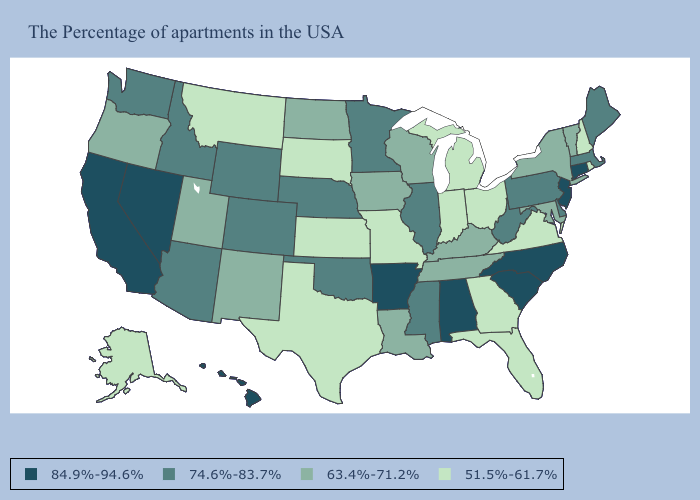Which states have the lowest value in the West?
Short answer required. Montana, Alaska. Among the states that border Missouri , does Tennessee have the highest value?
Be succinct. No. Does the map have missing data?
Write a very short answer. No. What is the value of Texas?
Concise answer only. 51.5%-61.7%. Name the states that have a value in the range 84.9%-94.6%?
Concise answer only. Connecticut, New Jersey, North Carolina, South Carolina, Alabama, Arkansas, Nevada, California, Hawaii. What is the value of New Mexico?
Short answer required. 63.4%-71.2%. Name the states that have a value in the range 84.9%-94.6%?
Short answer required. Connecticut, New Jersey, North Carolina, South Carolina, Alabama, Arkansas, Nevada, California, Hawaii. What is the value of Wyoming?
Answer briefly. 74.6%-83.7%. What is the value of Oklahoma?
Keep it brief. 74.6%-83.7%. What is the highest value in the USA?
Be succinct. 84.9%-94.6%. What is the lowest value in states that border Utah?
Answer briefly. 63.4%-71.2%. What is the value of Florida?
Answer briefly. 51.5%-61.7%. Does the first symbol in the legend represent the smallest category?
Answer briefly. No. What is the value of North Carolina?
Write a very short answer. 84.9%-94.6%. 